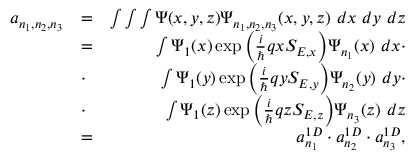Convert formula to latex. <formula><loc_0><loc_0><loc_500><loc_500>\begin{array} { r l r } { a _ { n _ { 1 } , n _ { 2 } , n _ { 3 } } } & { = } & { \int \int \int \Psi ( x , y , z ) \Psi _ { n _ { 1 } , n _ { 2 } , n _ { 3 } } ( x , y , z ) \ d x \ d y \ d z } \\ & { = } & { \int \Psi _ { 1 } ( x ) \exp { \left ( \frac { i } { } q x S _ { E , x } \right ) } \Psi _ { n _ { 1 } } ( x ) \ d x \cdot } \\ & { \cdot } & { \int \Psi _ { 1 } ( y ) \exp { \left ( \frac { i } { } q y S _ { E , y } \right ) } \Psi _ { n _ { 2 } } ( y ) \ d y \cdot } \\ & { \cdot } & { \int \Psi _ { 1 } ( z ) \exp { \left ( \frac { i } { } q z S _ { E , z } \right ) } \Psi _ { n _ { 3 } } ( z ) \ d z } \\ & { = } & { a _ { n _ { 1 } } ^ { 1 D } \cdot a _ { n _ { 2 } } ^ { 1 D } \cdot a _ { n _ { 3 } } ^ { 1 D } , } \end{array}</formula> 